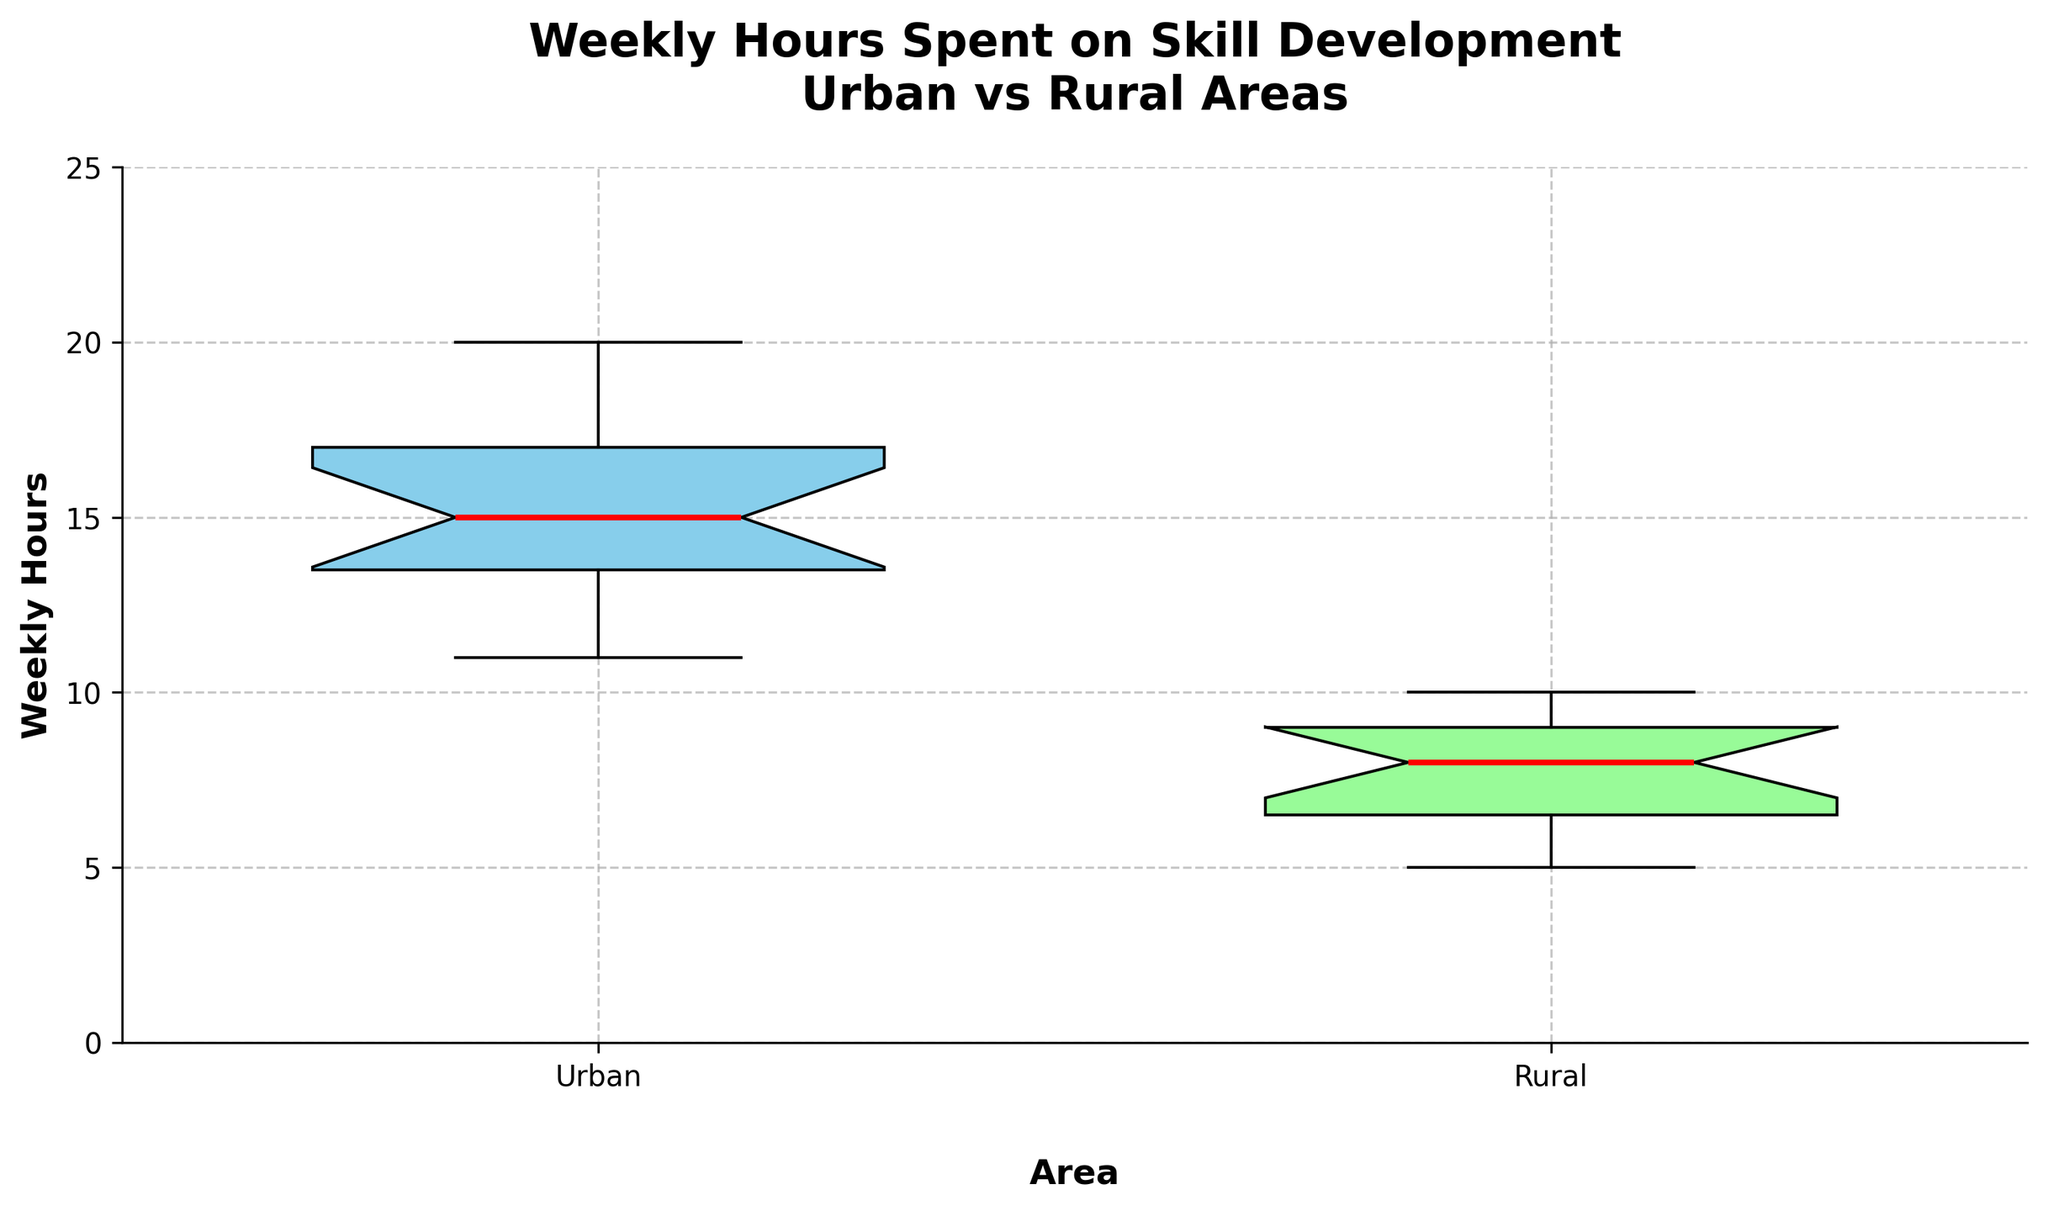what is the title of the figure? The title provides a succinct summary of what the figure displays. The title located at the top of the figure reads: 'Weekly Hours Spent on Skill Development\nUrban vs Rural Areas'.
Answer: Weekly Hours Spent on Skill Development\nUrban vs Rural Areas What does the y-axis represent? The y-axis is labeled to indicate it measures the weekly hours spent on skill development in both urban and rural areas.
Answer: Weekly Hours What group has the higher median weekly hours spent on skill development? The red line inside each box represents the median. By observing the boxes, the red line in the Urban group is higher compared to the Rural group.
Answer: Urban What is the approximate range of weekly hours spent on skill development for urban graduates? The box plot for the Urban group shows the interquartile range (IQR) and the whiskers which extend to the minimum and maximum values. The minimum value (lower whisker) is around 11 hours, and the maximum value (upper whisker) is around 20 hours.
Answer: 11 to 20 hours Which group has a greater interquartile range (IQR)? The IQR is determined by the distance between the lower and upper quartiles (the edges of the box). In the figure, the box plot for Urban graduates has a taller box compared to Rural, indicating a greater IQR.
Answer: Urban Do the notches of the box plots overlap? Notches in the box plots indicate the confidence interval around the median. If the notches do not overlap, it suggests the medians are significantly different. Observing the graph, the notches for Urban and Rural do not overlap.
Answer: No How many outliers are present in the Urban group's data? Outliers are marked by distinct dots or diamonds outside the whiskers. In the figure, no outliers are visible in the Urban group's data.
Answer: 0 What is the maximum value for the Rural group? The maximum value for the Rural group is at the top of the upper whisker. From the graph, the topmost point aligns with 10 hours.
Answer: 10 hours What is the median value for the Rural group? The median is represented by the thick middle line inside the box. For the Rural group, this line is around 8 hours.
Answer: 8 hours 